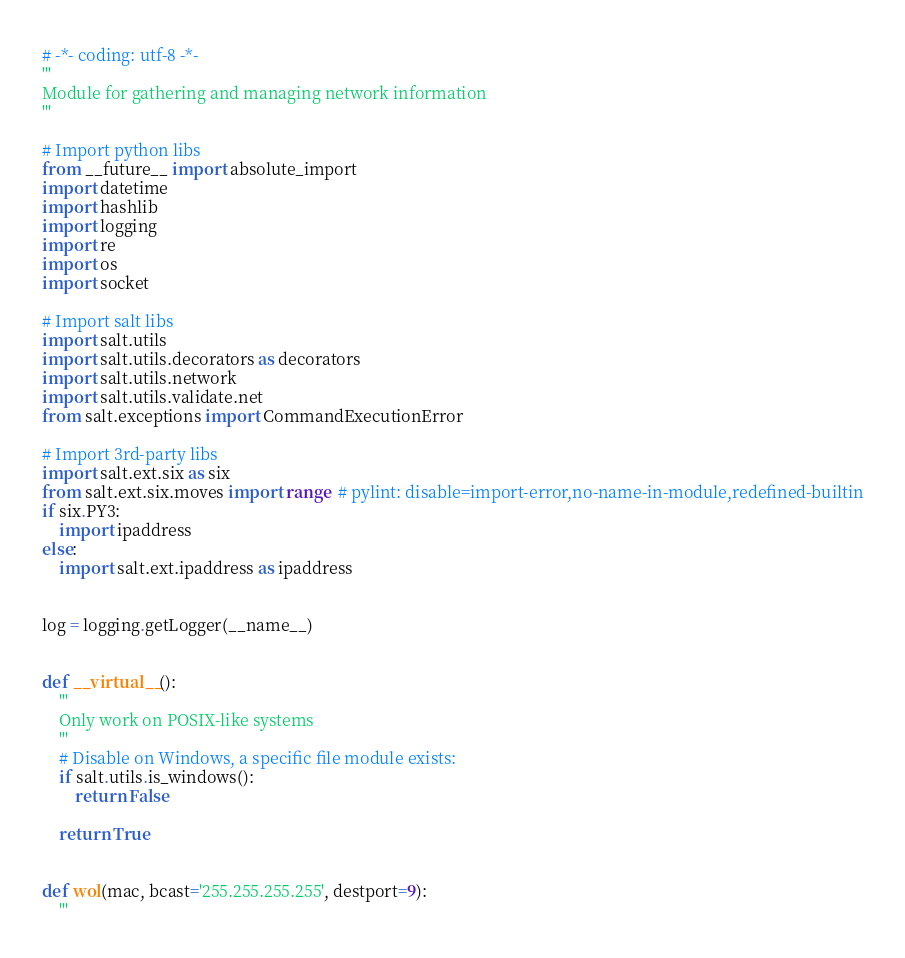Convert code to text. <code><loc_0><loc_0><loc_500><loc_500><_Python_># -*- coding: utf-8 -*-
'''
Module for gathering and managing network information
'''

# Import python libs
from __future__ import absolute_import
import datetime
import hashlib
import logging
import re
import os
import socket

# Import salt libs
import salt.utils
import salt.utils.decorators as decorators
import salt.utils.network
import salt.utils.validate.net
from salt.exceptions import CommandExecutionError

# Import 3rd-party libs
import salt.ext.six as six
from salt.ext.six.moves import range  # pylint: disable=import-error,no-name-in-module,redefined-builtin
if six.PY3:
    import ipaddress
else:
    import salt.ext.ipaddress as ipaddress


log = logging.getLogger(__name__)


def __virtual__():
    '''
    Only work on POSIX-like systems
    '''
    # Disable on Windows, a specific file module exists:
    if salt.utils.is_windows():
        return False

    return True


def wol(mac, bcast='255.255.255.255', destport=9):
    '''</code> 